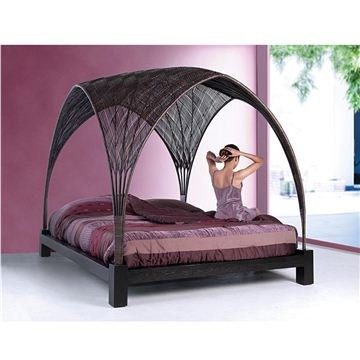Describe the objects in this image and their specific colors. I can see bed in white, black, gray, and lavender tones and people in white, gray, and lightpink tones in this image. 